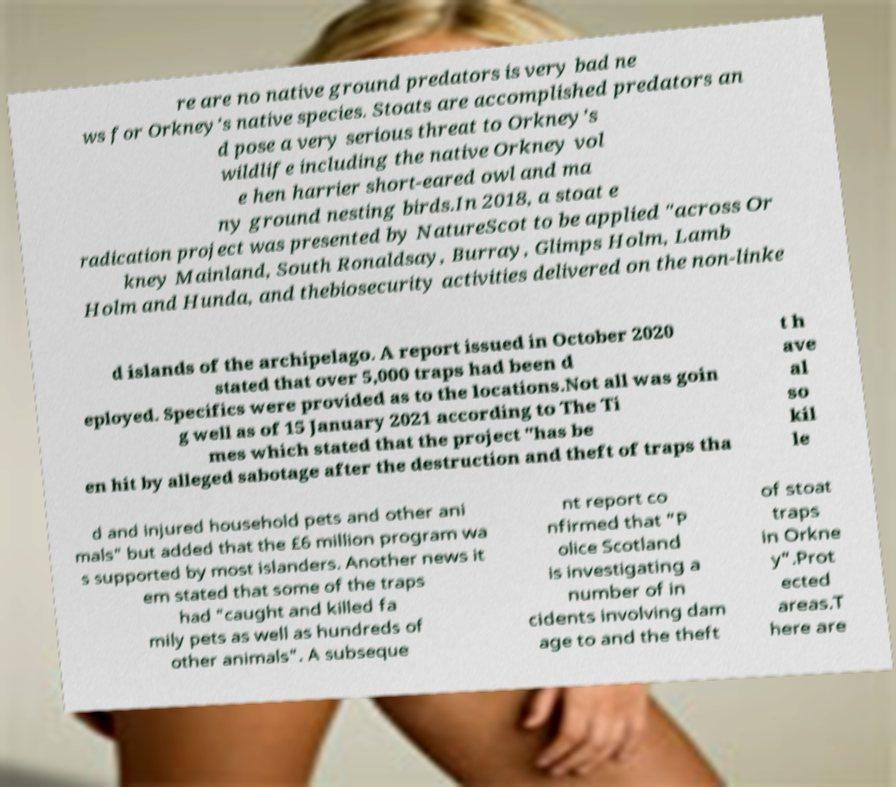I need the written content from this picture converted into text. Can you do that? re are no native ground predators is very bad ne ws for Orkney’s native species. Stoats are accomplished predators an d pose a very serious threat to Orkney’s wildlife including the native Orkney vol e hen harrier short-eared owl and ma ny ground nesting birds.In 2018, a stoat e radication project was presented by NatureScot to be applied "across Or kney Mainland, South Ronaldsay, Burray, Glimps Holm, Lamb Holm and Hunda, and thebiosecurity activities delivered on the non-linke d islands of the archipelago. A report issued in October 2020 stated that over 5,000 traps had been d eployed. Specifics were provided as to the locations.Not all was goin g well as of 15 January 2021 according to The Ti mes which stated that the project "has be en hit by alleged sabotage after the destruction and theft of traps tha t h ave al so kil le d and injured household pets and other ani mals" but added that the £6 million program wa s supported by most islanders. Another news it em stated that some of the traps had "caught and killed fa mily pets as well as hundreds of other animals". A subseque nt report co nfirmed that "P olice Scotland is investigating a number of in cidents involving dam age to and the theft of stoat traps in Orkne y".Prot ected areas.T here are 